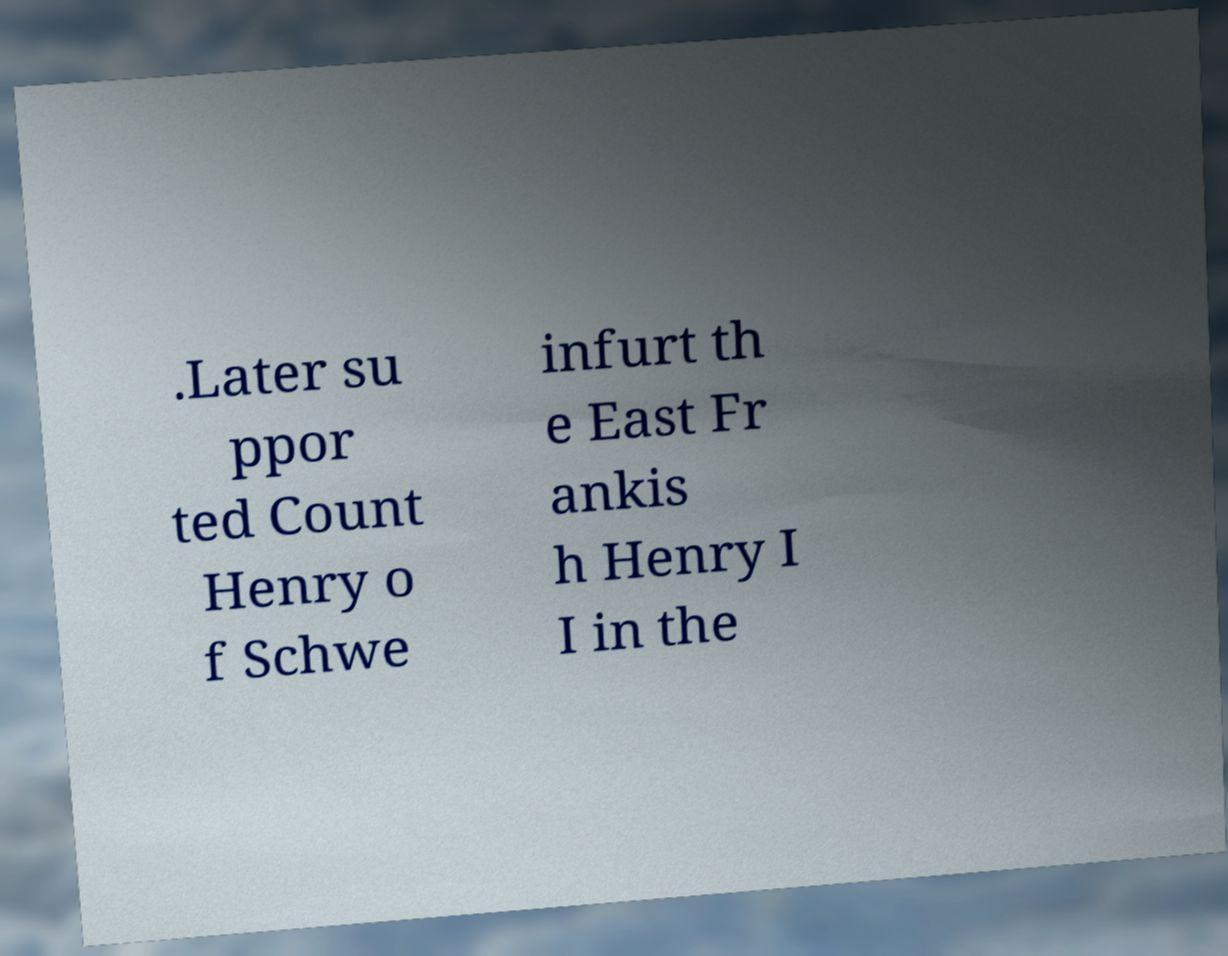I need the written content from this picture converted into text. Can you do that? .Later su ppor ted Count Henry o f Schwe infurt th e East Fr ankis h Henry I I in the 